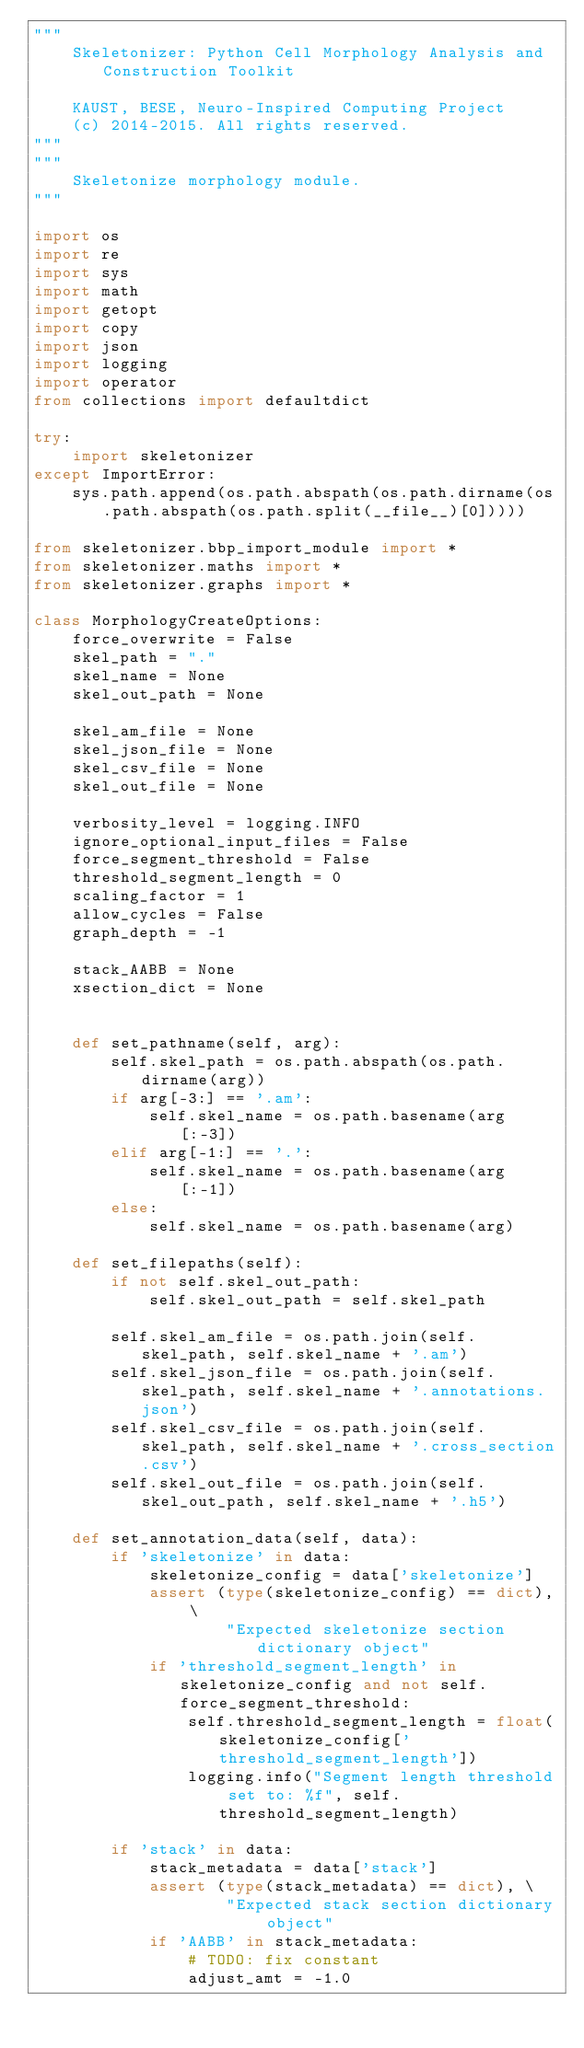<code> <loc_0><loc_0><loc_500><loc_500><_Python_>"""
    Skeletonizer: Python Cell Morphology Analysis and Construction Toolkit

    KAUST, BESE, Neuro-Inspired Computing Project
    (c) 2014-2015. All rights reserved.
"""
"""
    Skeletonize morphology module.
"""

import os
import re
import sys
import math
import getopt
import copy
import json
import logging
import operator
from collections import defaultdict

try:
    import skeletonizer
except ImportError:
    sys.path.append(os.path.abspath(os.path.dirname(os.path.abspath(os.path.split(__file__)[0]))))

from skeletonizer.bbp_import_module import *
from skeletonizer.maths import *
from skeletonizer.graphs import *

class MorphologyCreateOptions:
    force_overwrite = False
    skel_path = "."
    skel_name = None
    skel_out_path = None

    skel_am_file = None
    skel_json_file = None
    skel_csv_file = None
    skel_out_file = None

    verbosity_level = logging.INFO
    ignore_optional_input_files = False
    force_segment_threshold = False
    threshold_segment_length = 0
    scaling_factor = 1
    allow_cycles = False
    graph_depth = -1

    stack_AABB = None
    xsection_dict = None


    def set_pathname(self, arg):
        self.skel_path = os.path.abspath(os.path.dirname(arg))
        if arg[-3:] == '.am':
            self.skel_name = os.path.basename(arg[:-3])
        elif arg[-1:] == '.':
            self.skel_name = os.path.basename(arg[:-1])
        else:
            self.skel_name = os.path.basename(arg)

    def set_filepaths(self):
        if not self.skel_out_path:
            self.skel_out_path = self.skel_path

        self.skel_am_file = os.path.join(self.skel_path, self.skel_name + '.am')
        self.skel_json_file = os.path.join(self.skel_path, self.skel_name + '.annotations.json')
        self.skel_csv_file = os.path.join(self.skel_path, self.skel_name + '.cross_section.csv')
        self.skel_out_file = os.path.join(self.skel_out_path, self.skel_name + '.h5')

    def set_annotation_data(self, data):
        if 'skeletonize' in data:
            skeletonize_config = data['skeletonize']
            assert (type(skeletonize_config) == dict), \
                    "Expected skeletonize section dictionary object"
            if 'threshold_segment_length' in skeletonize_config and not self.force_segment_threshold:
                self.threshold_segment_length = float(skeletonize_config['threshold_segment_length'])
                logging.info("Segment length threshold set to: %f", self.threshold_segment_length)

        if 'stack' in data:
            stack_metadata = data['stack']
            assert (type(stack_metadata) == dict), \
                    "Expected stack section dictionary object"
            if 'AABB' in stack_metadata:
                # TODO: fix constant
                adjust_amt = -1.0</code> 